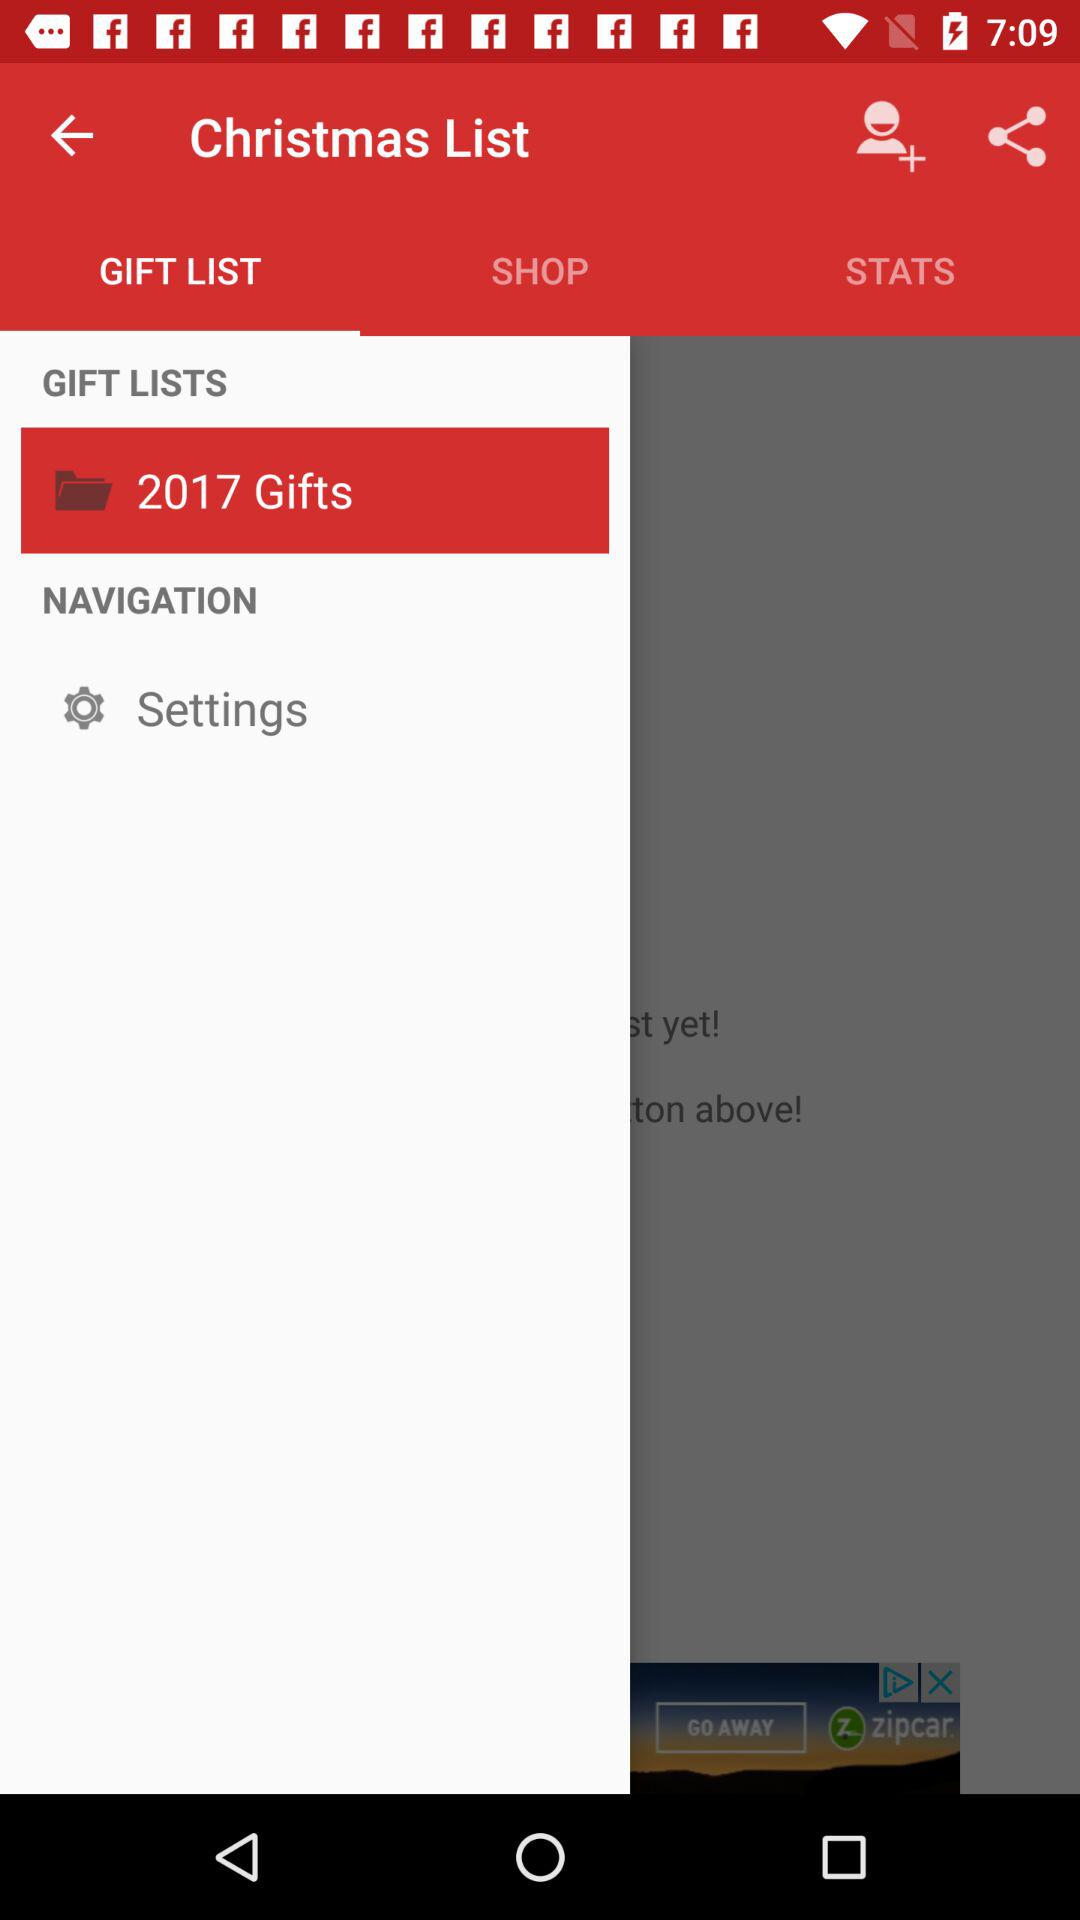Which tab is selected? The selected tab is "GIFT LIST". 